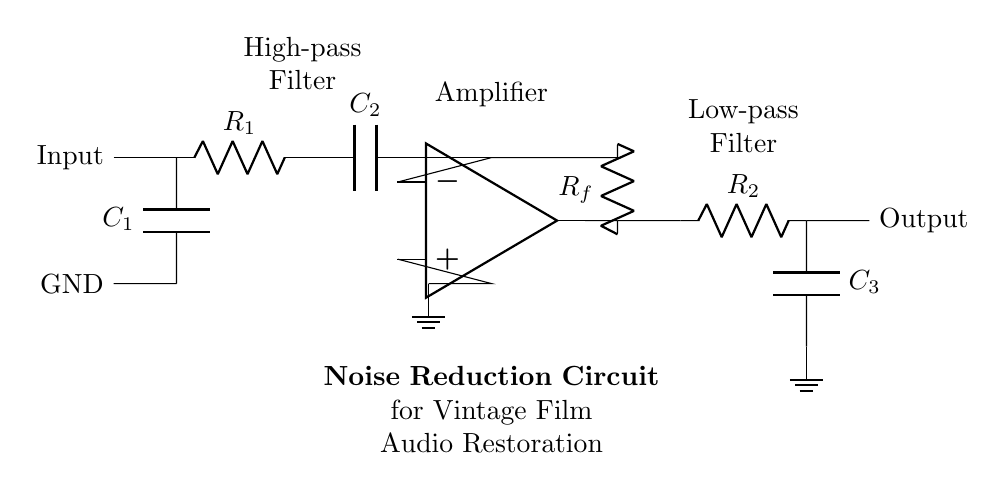What is the purpose of the capacitor C1? Capacitor C1 is connected in series with the input signal, serving as a coupling capacitor. Its primary purpose is to block any DC offset from the input signal while allowing AC signals to pass through, thus protecting downstream components.
Answer: Coupling What type of filter does the resistor R1 and capacitor C2 form? Resistor R1 and capacitor C2 are in series, making them function as a high-pass filter. This configuration will allow frequencies above a certain cutoff frequency to pass while attenuating frequencies lower than this threshold.
Answer: High-pass filter What is the configuration of the operational amplifier in this circuit? The operational amplifier is configured as a non-inverting amplifier, indicated by its positive and negative inputs and the feedback loop connecting from its output to the input. This configuration provides voltage gain to the incoming audio signal.
Answer: Non-inverting What is the role of the feedback resistor Rf? Resistor Rf is part of the feedback network that controls the gain of the operational amplifier. By adjusting the resistance, it directly influences the output voltage relative to the input voltage, thereby regulating the amplification factor of the circuit.
Answer: Gain control What type of filter is created by R2 and C3? Resistor R2 and capacitor C3 are connected in series to form a low-pass filter. This arrangement allows signals with frequencies lower than a certain cutoff frequency to pass through while attenuating higher frequencies, which is essential for smoothing the output signal.
Answer: Low-pass filter 